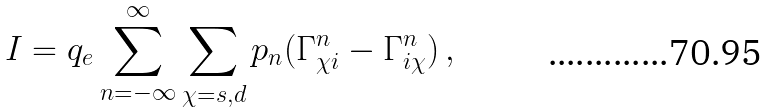Convert formula to latex. <formula><loc_0><loc_0><loc_500><loc_500>I = q _ { e } \sum _ { n = - \infty } ^ { \infty } \sum _ { \chi = s , d } p _ { n } ( \Gamma ^ { n } _ { \chi i } - \Gamma ^ { n } _ { i \chi } ) \, ,</formula> 